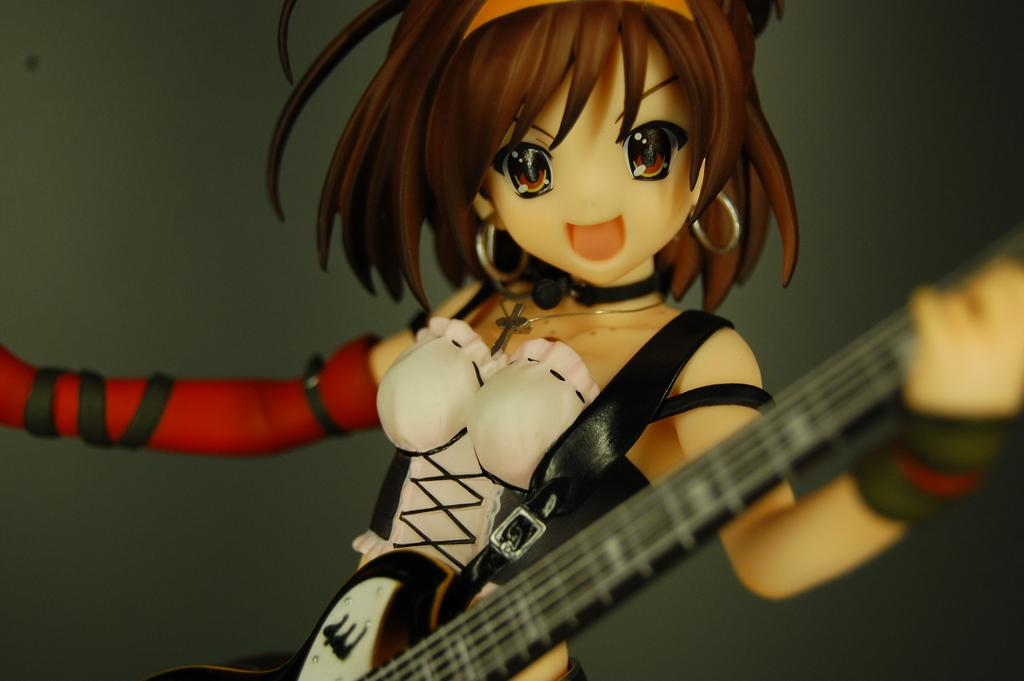What type of character is depicted in the image? There is a cartoon character in the image. What type of skin condition does the cartoon character have in the image? There is no information about the cartoon character's skin condition in the image, as it is a cartoon character and not a real person. 